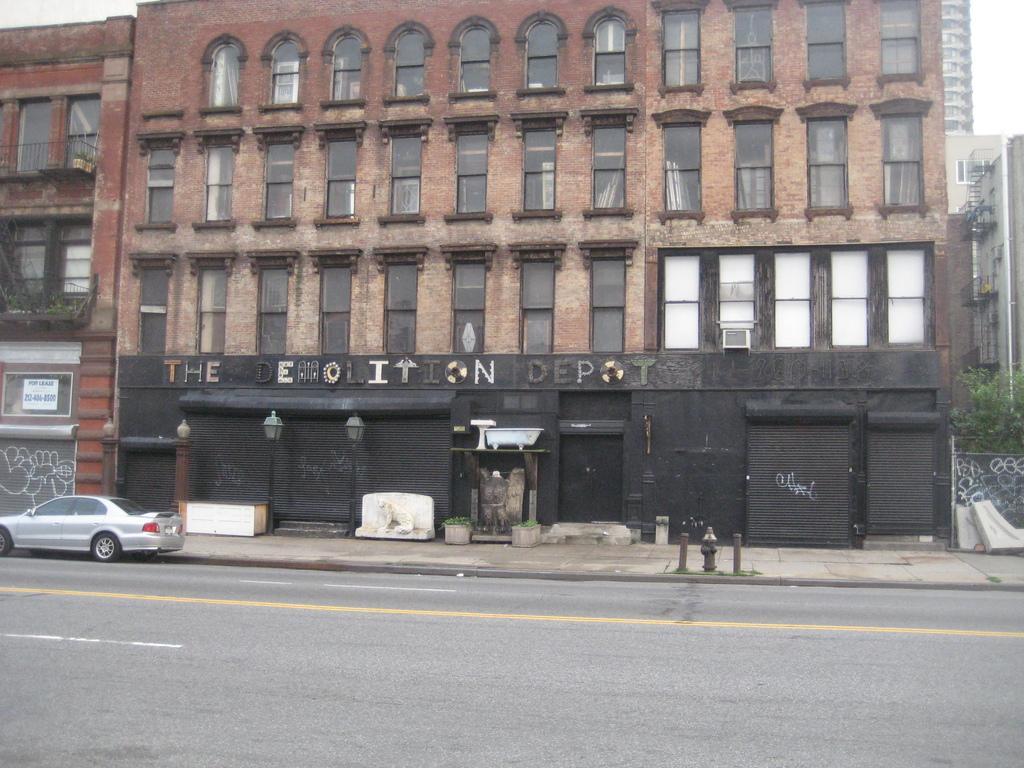How would you summarize this image in a sentence or two? In this image there are buildings, in front of the buildings there are closed shutters with lamps and name on it, in front of the building on the pavement there are water pipes and there is a car on the road. 